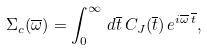Convert formula to latex. <formula><loc_0><loc_0><loc_500><loc_500>\Sigma _ { c } ( \overline { \omega } ) = \int _ { 0 } ^ { \infty } \, d \overline { t } \, C _ { J } ( \overline { t } ) \, e ^ { i \overline { \omega } \, \overline { t } } ,</formula> 